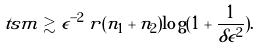Convert formula to latex. <formula><loc_0><loc_0><loc_500><loc_500>\ t s m \gtrsim \epsilon ^ { - 2 } \, r ( n _ { 1 } + n _ { 2 } ) \log ( 1 + \frac { 1 } { \delta \epsilon ^ { 2 } } ) .</formula> 